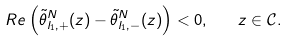<formula> <loc_0><loc_0><loc_500><loc_500>R e \left ( \tilde { \theta } _ { l _ { 1 } , + } ^ { N } ( z ) - \tilde { \theta } _ { l _ { 1 } , - } ^ { N } ( z ) \right ) < 0 , \quad z \in \mathcal { C } .</formula> 